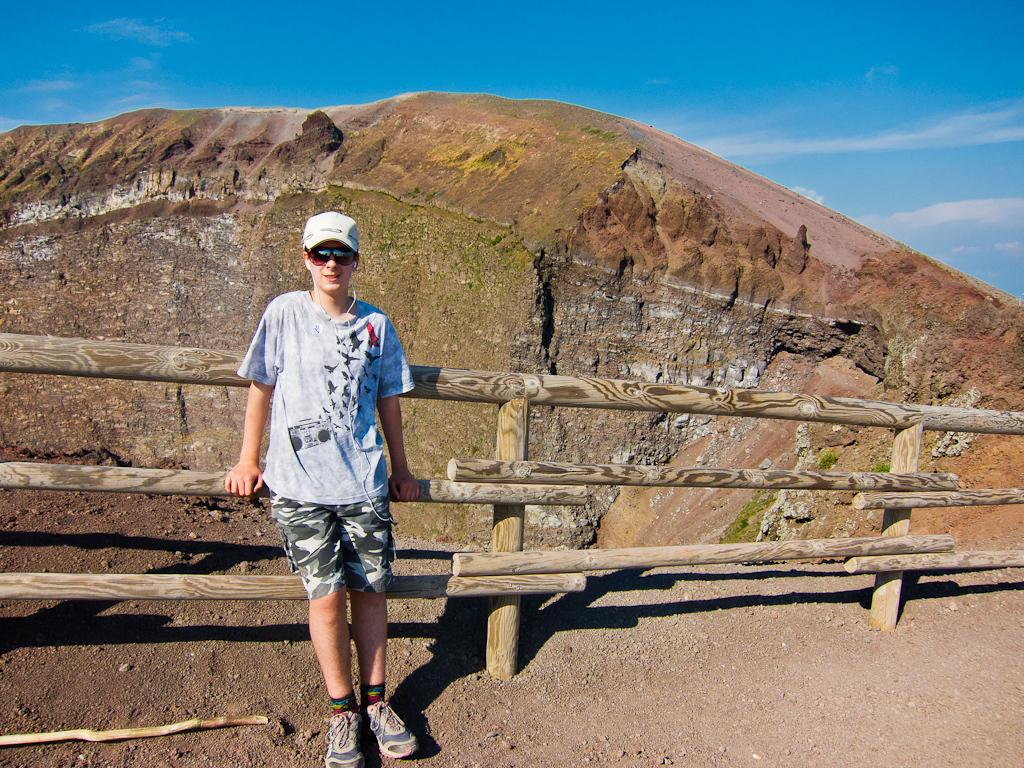What is the main subject of the image? There is a man standing in the image. Can you describe the man's attire? The man is wearing clothes, socks, shoes, goggles, and a cap. What can be seen in the background of the image? There is a wooden fence, sand, a mountain, and the sky visible in the image. What type of finger food is the man eating for breakfast in the image? There is no finger food or indication of breakfast in the image. What type of vessel is the man using to transport water in the image? There is no vessel or water present in the image. 